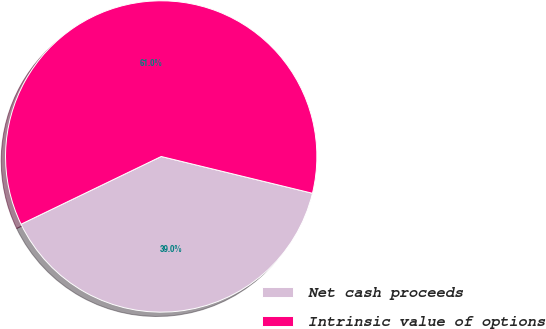Convert chart to OTSL. <chart><loc_0><loc_0><loc_500><loc_500><pie_chart><fcel>Net cash proceeds<fcel>Intrinsic value of options<nl><fcel>39.04%<fcel>60.96%<nl></chart> 